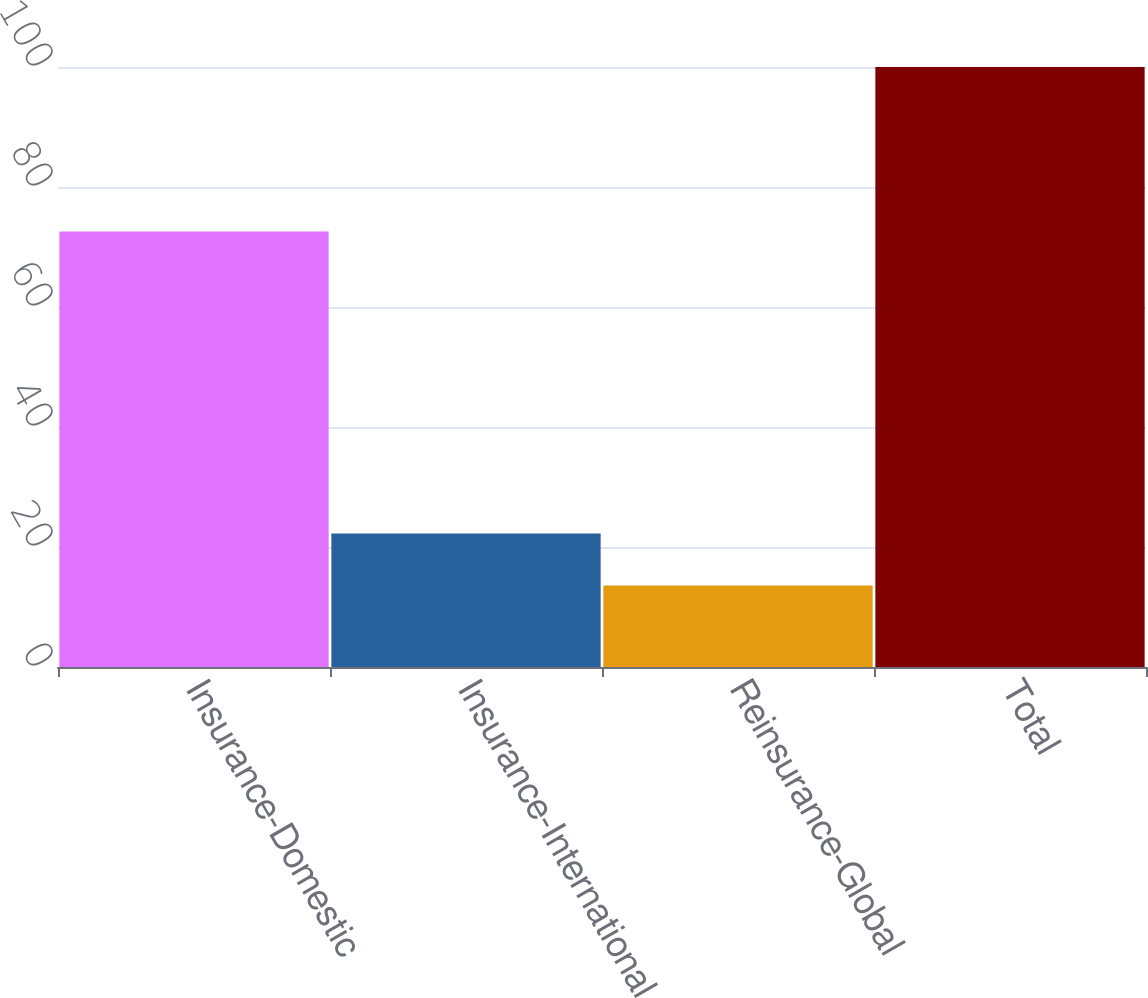<chart> <loc_0><loc_0><loc_500><loc_500><bar_chart><fcel>Insurance-Domestic<fcel>Insurance-International<fcel>Reinsurance-Global<fcel>Total<nl><fcel>72.6<fcel>22.24<fcel>13.6<fcel>100<nl></chart> 